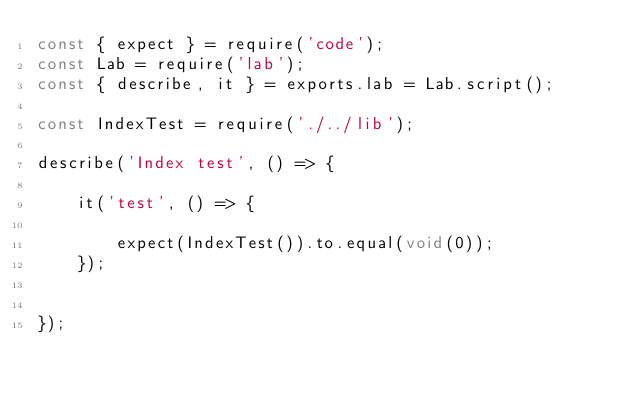<code> <loc_0><loc_0><loc_500><loc_500><_JavaScript_>const { expect } = require('code');
const Lab = require('lab');
const { describe, it } = exports.lab = Lab.script();

const IndexTest = require('./../lib');

describe('Index test', () => {
        
    it('test', () => {

        expect(IndexTest()).to.equal(void(0));
    });


});
</code> 